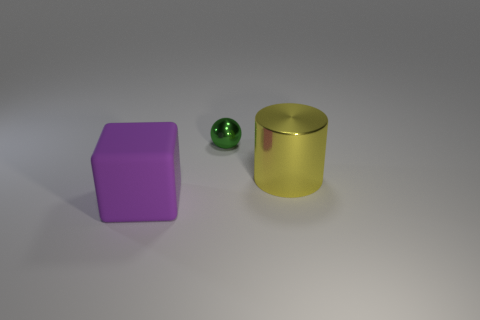There is a thing that is made of the same material as the sphere; what shape is it? The object made of the same material as the sphere is the cylinder. You can identify this by the metallic sheen and the consistent color reflective properties on both objects. 